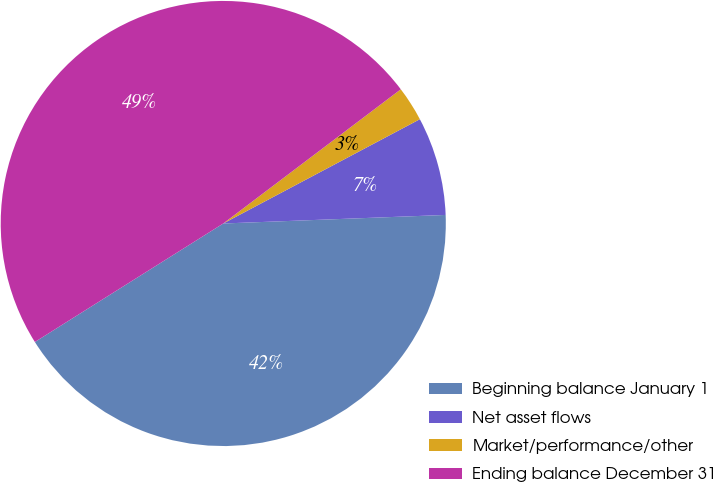Convert chart. <chart><loc_0><loc_0><loc_500><loc_500><pie_chart><fcel>Beginning balance January 1<fcel>Net asset flows<fcel>Market/performance/other<fcel>Ending balance December 31<nl><fcel>41.68%<fcel>7.15%<fcel>2.54%<fcel>48.64%<nl></chart> 